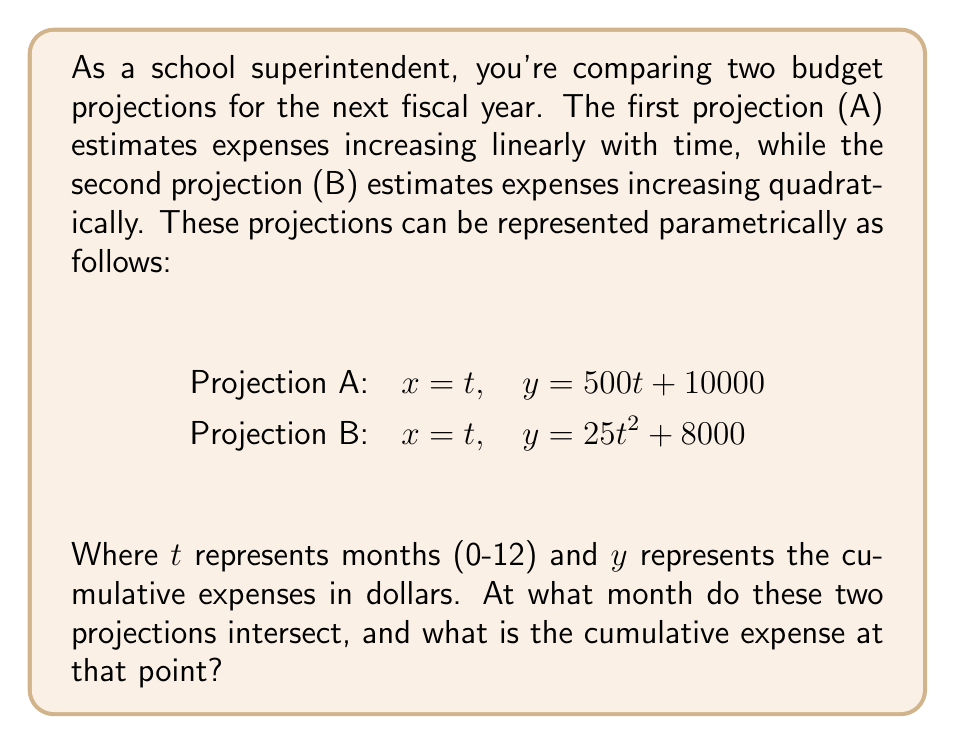Can you solve this math problem? To find the intersection of these two parametric equations, we need to equate their y-components:

$$500t + 10000 = 25t^2 + 8000$$

Rearranging the equation:

$$25t^2 - 500t - 2000 = 0$$

This is a quadratic equation in the form $at^2 + bt + c = 0$, where:
$a = 25$, $b = -500$, and $c = -2000$

We can solve this using the quadratic formula: $t = \frac{-b \pm \sqrt{b^2 - 4ac}}{2a}$

$$t = \frac{500 \pm \sqrt{(-500)^2 - 4(25)(-2000)}}{2(25)}$$

$$t = \frac{500 \pm \sqrt{250000 + 200000}}{50}$$

$$t = \frac{500 \pm \sqrt{450000}}{50}$$

$$t = \frac{500 \pm 670.82}{50}$$

This gives us two solutions:
$t_1 = \frac{500 + 670.82}{50} \approx 23.42$
$t_2 = \frac{500 - 670.82}{50} \approx -3.42$

Since we're dealing with months in the range 0-12, we can discard the negative solution. The positive solution is also outside our range, so we'll round down to the nearest month within our range.

$t \approx 12$ months

To find the cumulative expense at this point, we can substitute $t=12$ into either of the original equations. Let's use Projection A:

$y = 500(12) + 10000 = 16000$
Answer: The two budget projections intersect at approximately 12 months, with a cumulative expense of $16,000. 